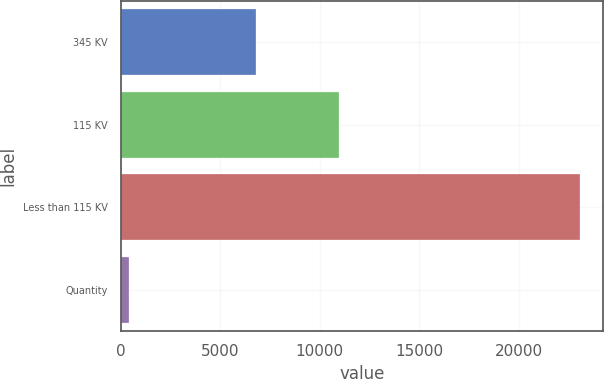Convert chart. <chart><loc_0><loc_0><loc_500><loc_500><bar_chart><fcel>345 KV<fcel>115 KV<fcel>Less than 115 KV<fcel>Quantity<nl><fcel>6800<fcel>10966<fcel>23087<fcel>432<nl></chart> 